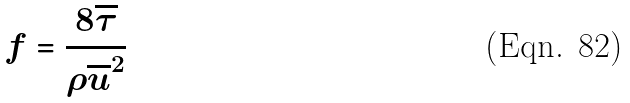<formula> <loc_0><loc_0><loc_500><loc_500>f = \frac { 8 \overline { \tau } } { \rho \overline { u } ^ { 2 } }</formula> 